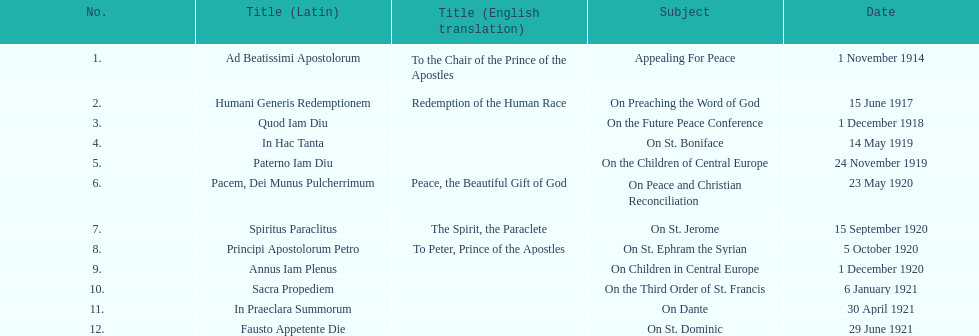What is the next title listed after sacra propediem? In Praeclara Summorum. 